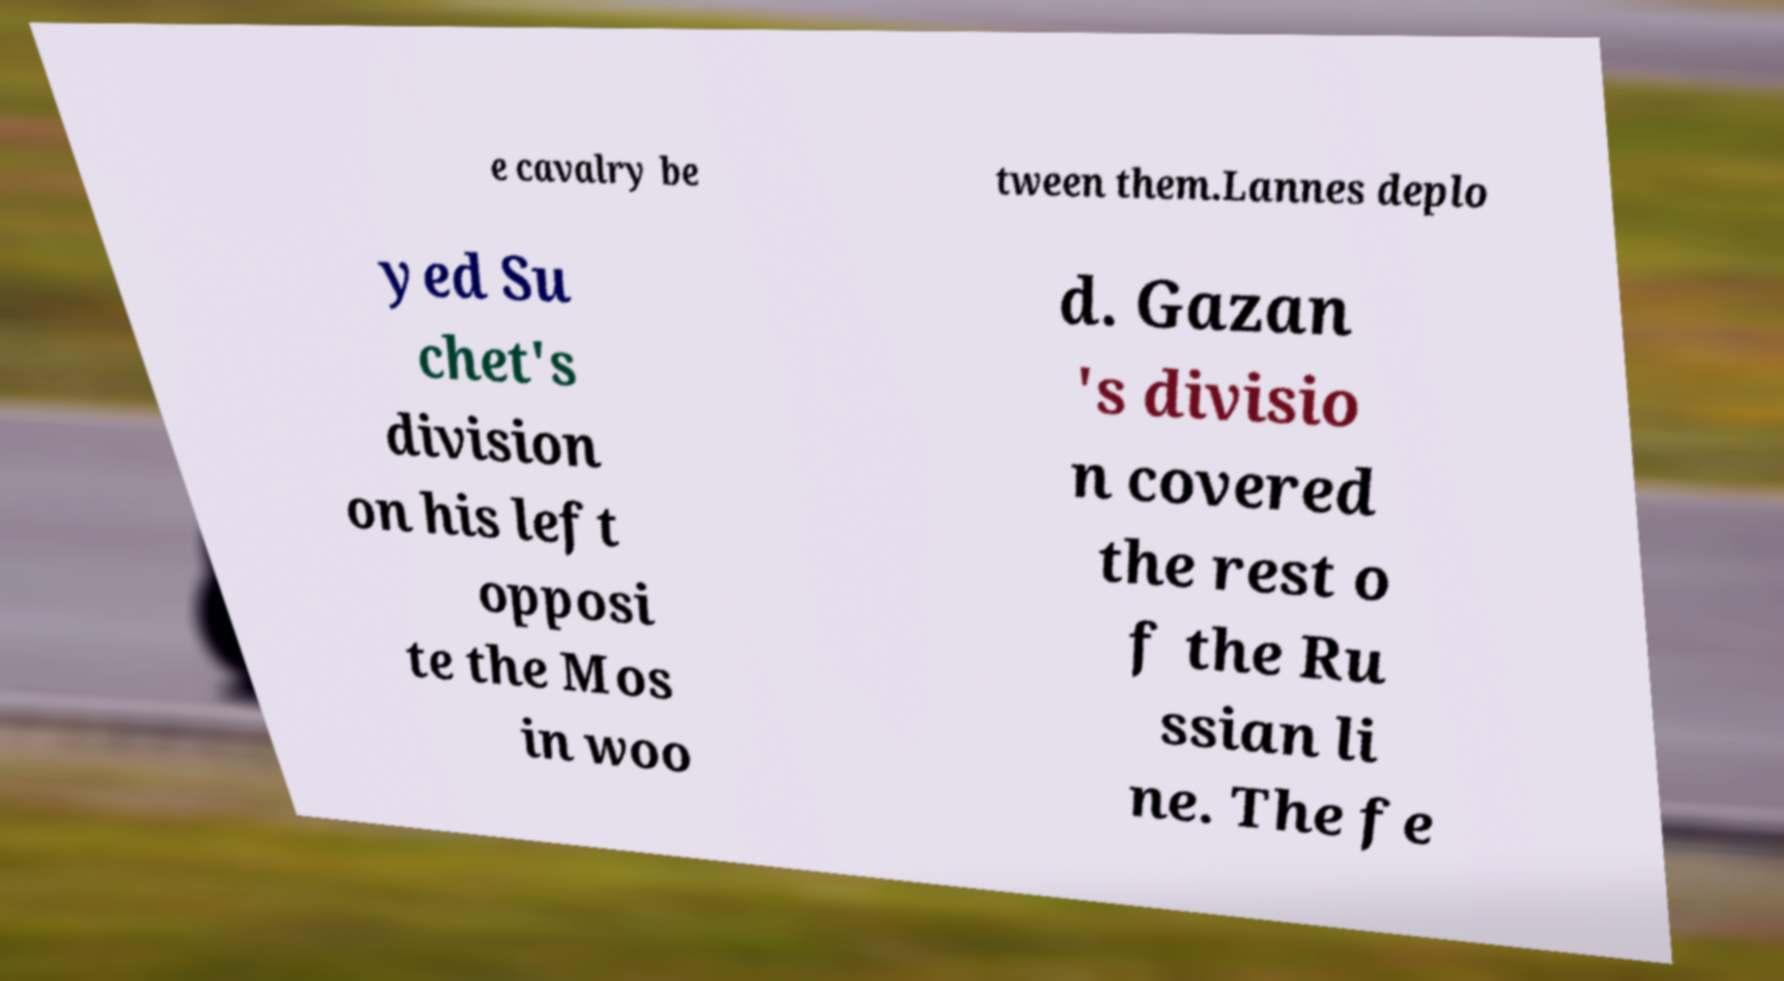Please identify and transcribe the text found in this image. e cavalry be tween them.Lannes deplo yed Su chet's division on his left opposi te the Mos in woo d. Gazan 's divisio n covered the rest o f the Ru ssian li ne. The fe 